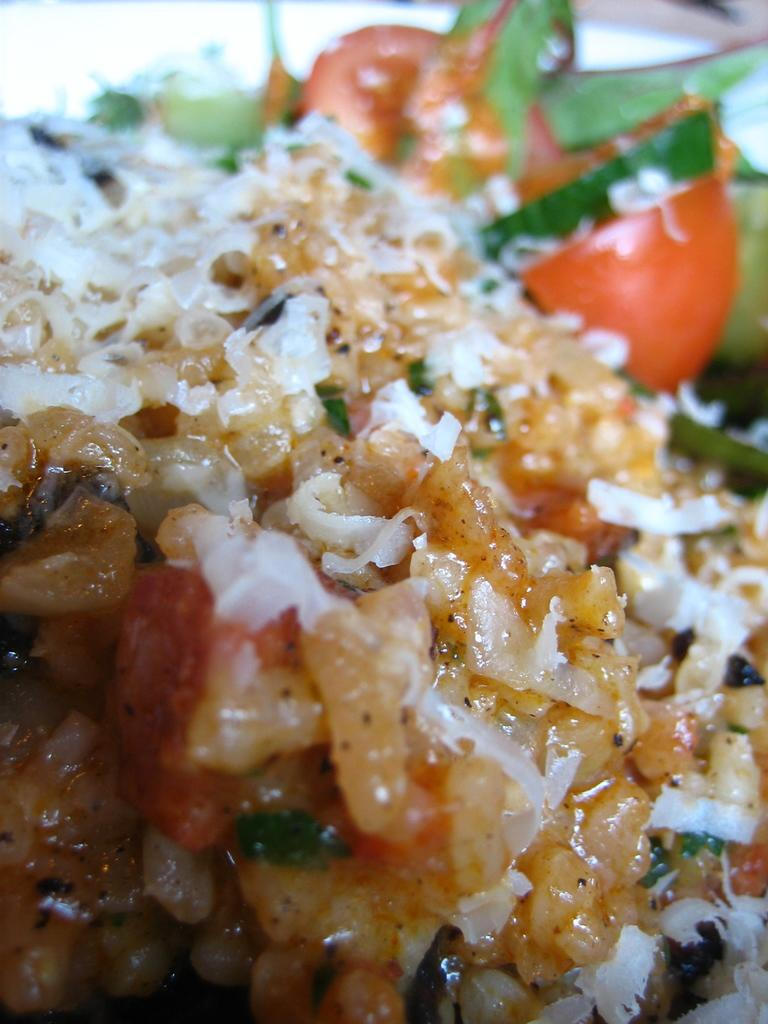What type of food item is visible in the image? There is a food item in the image, but the specific type cannot be determined from the provided facts. What ingredients can be found in the food item? The food item contains onion pieces, tomato pieces, and other vegetable pieces. Can you describe the background of the image? The background of the image is blurred. How many kittens are sitting on the rail in the image? There are no kittens or rails present in the image. 